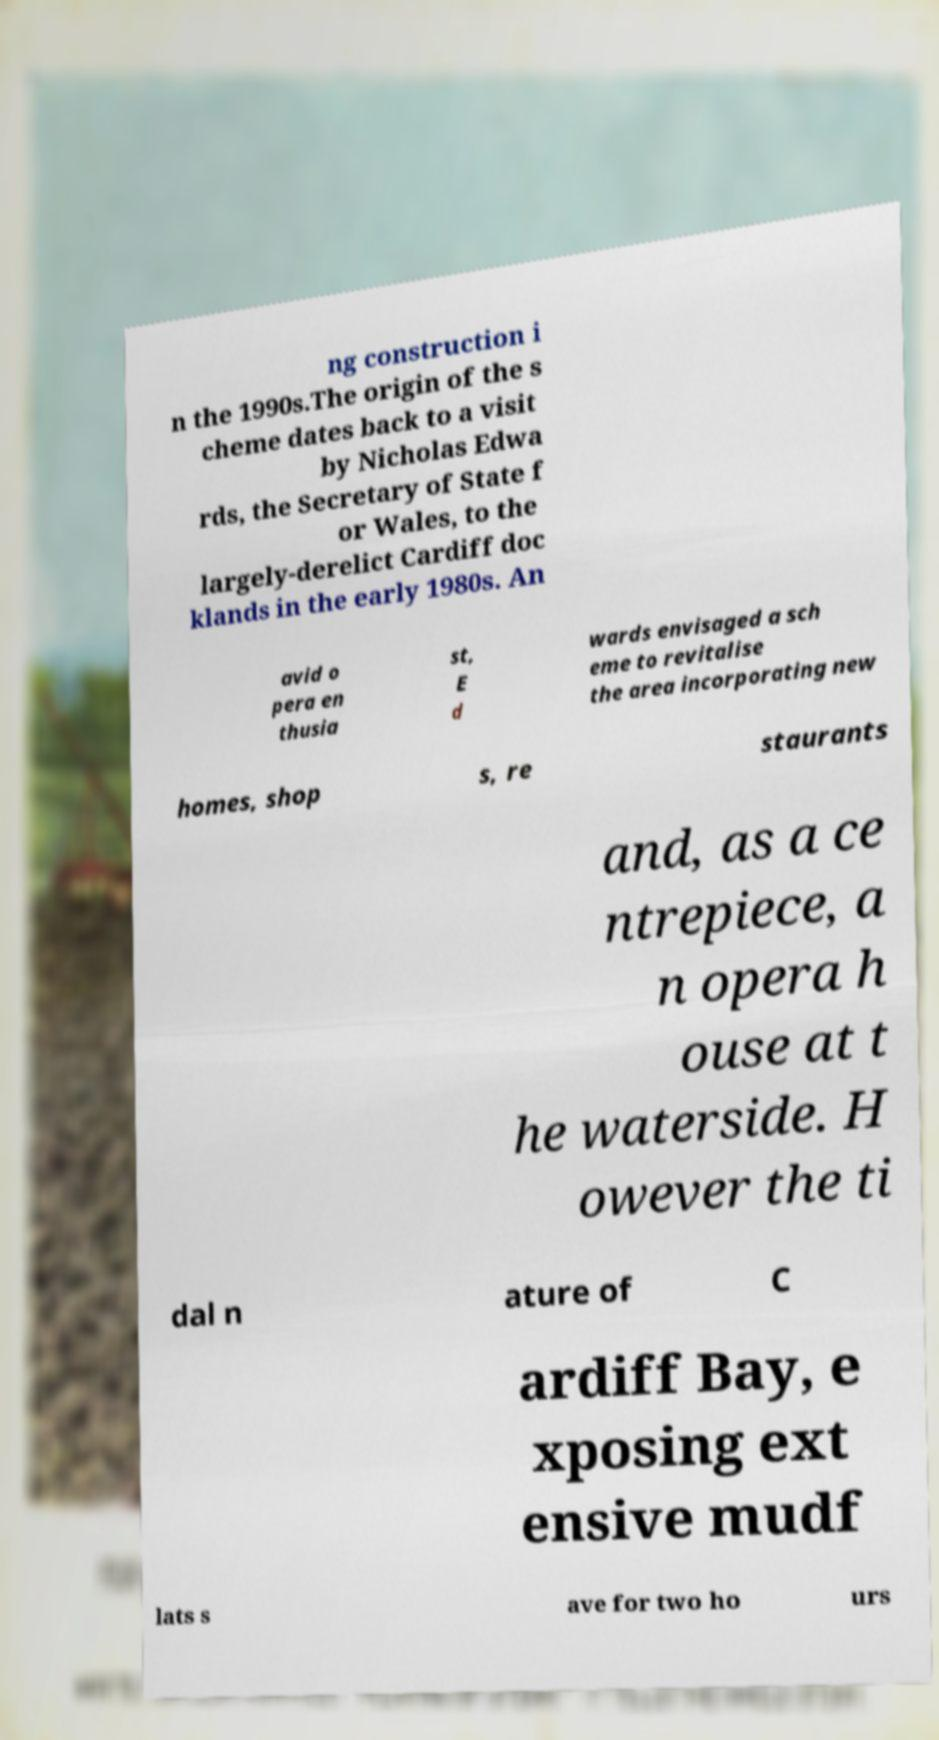There's text embedded in this image that I need extracted. Can you transcribe it verbatim? ng construction i n the 1990s.The origin of the s cheme dates back to a visit by Nicholas Edwa rds, the Secretary of State f or Wales, to the largely-derelict Cardiff doc klands in the early 1980s. An avid o pera en thusia st, E d wards envisaged a sch eme to revitalise the area incorporating new homes, shop s, re staurants and, as a ce ntrepiece, a n opera h ouse at t he waterside. H owever the ti dal n ature of C ardiff Bay, e xposing ext ensive mudf lats s ave for two ho urs 